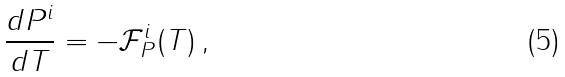Convert formula to latex. <formula><loc_0><loc_0><loc_500><loc_500>\frac { d P ^ { i } } { d T } = - \mathcal { F } ^ { i } _ { P } ( T ) \, ,</formula> 